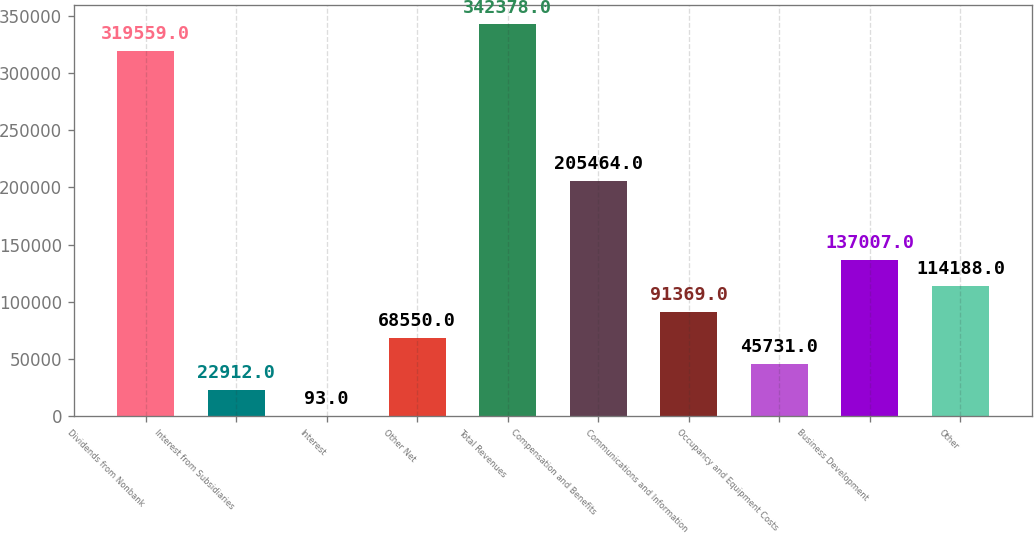<chart> <loc_0><loc_0><loc_500><loc_500><bar_chart><fcel>Dividends from Nonbank<fcel>Interest from Subsidiaries<fcel>Interest<fcel>Other Net<fcel>Total Revenues<fcel>Compensation and Benefits<fcel>Communications and Information<fcel>Occupancy and Equipment Costs<fcel>Business Development<fcel>Other<nl><fcel>319559<fcel>22912<fcel>93<fcel>68550<fcel>342378<fcel>205464<fcel>91369<fcel>45731<fcel>137007<fcel>114188<nl></chart> 